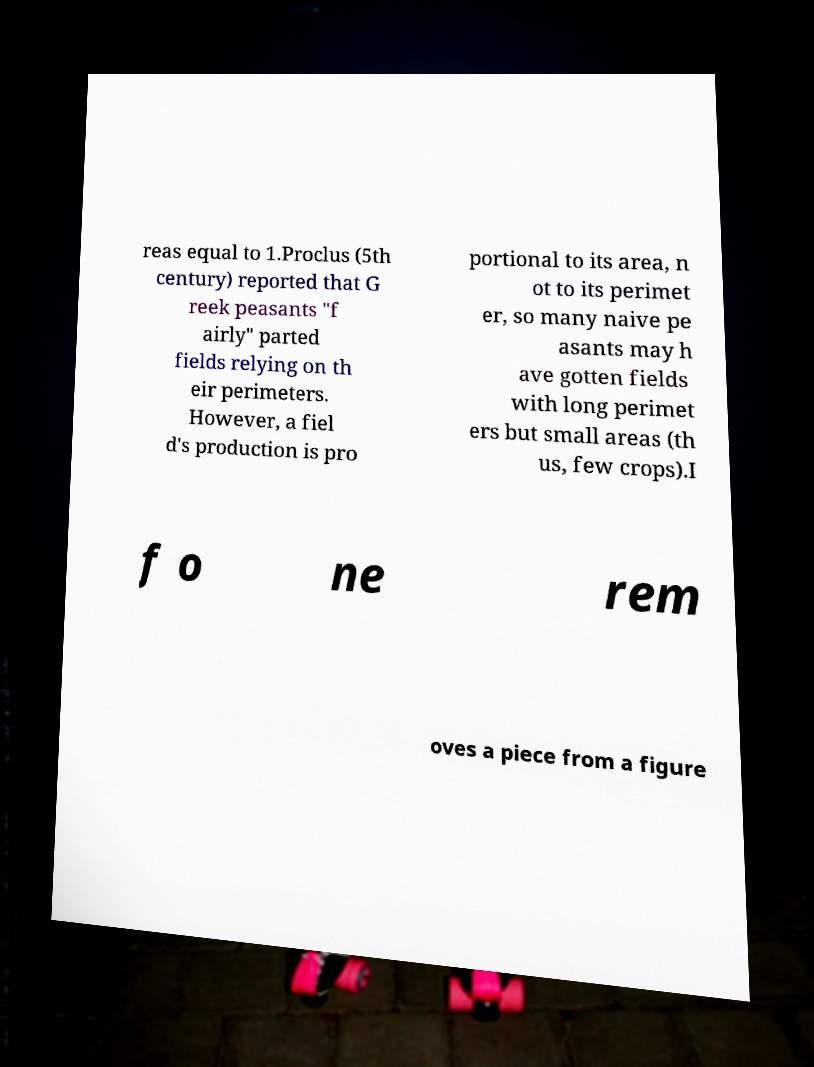Could you assist in decoding the text presented in this image and type it out clearly? reas equal to 1.Proclus (5th century) reported that G reek peasants "f airly" parted fields relying on th eir perimeters. However, a fiel d's production is pro portional to its area, n ot to its perimet er, so many naive pe asants may h ave gotten fields with long perimet ers but small areas (th us, few crops).I f o ne rem oves a piece from a figure 